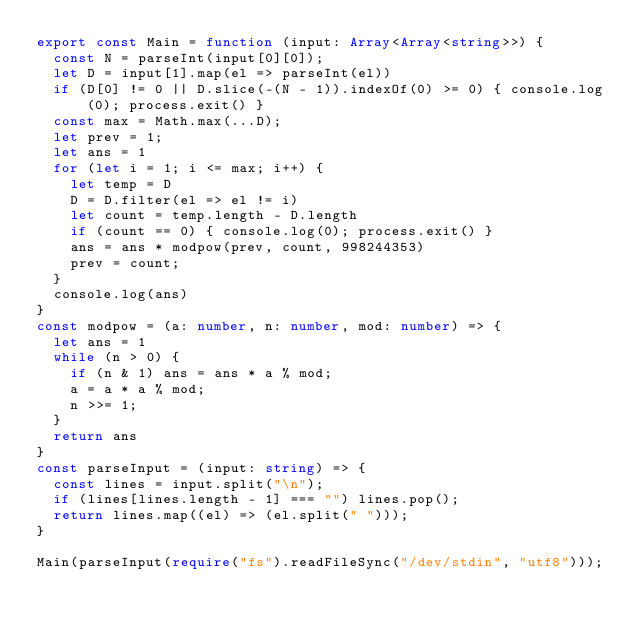<code> <loc_0><loc_0><loc_500><loc_500><_TypeScript_>export const Main = function (input: Array<Array<string>>) {
  const N = parseInt(input[0][0]);
  let D = input[1].map(el => parseInt(el))
  if (D[0] != 0 || D.slice(-(N - 1)).indexOf(0) >= 0) { console.log(0); process.exit() }
  const max = Math.max(...D);
  let prev = 1;
  let ans = 1
  for (let i = 1; i <= max; i++) {
    let temp = D
    D = D.filter(el => el != i)
    let count = temp.length - D.length
    if (count == 0) { console.log(0); process.exit() }
    ans = ans * modpow(prev, count, 998244353)
    prev = count;
  }
  console.log(ans)
}
const modpow = (a: number, n: number, mod: number) => {
  let ans = 1
  while (n > 0) {
    if (n & 1) ans = ans * a % mod;
    a = a * a % mod;
    n >>= 1;
  }
  return ans
}
const parseInput = (input: string) => {
  const lines = input.split("\n");
  if (lines[lines.length - 1] === "") lines.pop();
  return lines.map((el) => (el.split(" ")));
}

Main(parseInput(require("fs").readFileSync("/dev/stdin", "utf8")));
</code> 